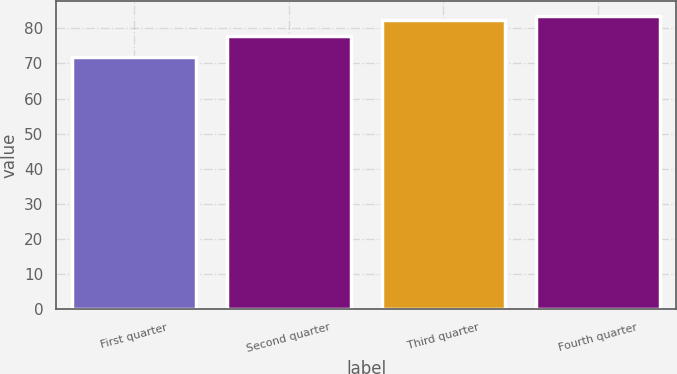<chart> <loc_0><loc_0><loc_500><loc_500><bar_chart><fcel>First quarter<fcel>Second quarter<fcel>Third quarter<fcel>Fourth quarter<nl><fcel>71.97<fcel>77.78<fcel>82.4<fcel>83.56<nl></chart> 